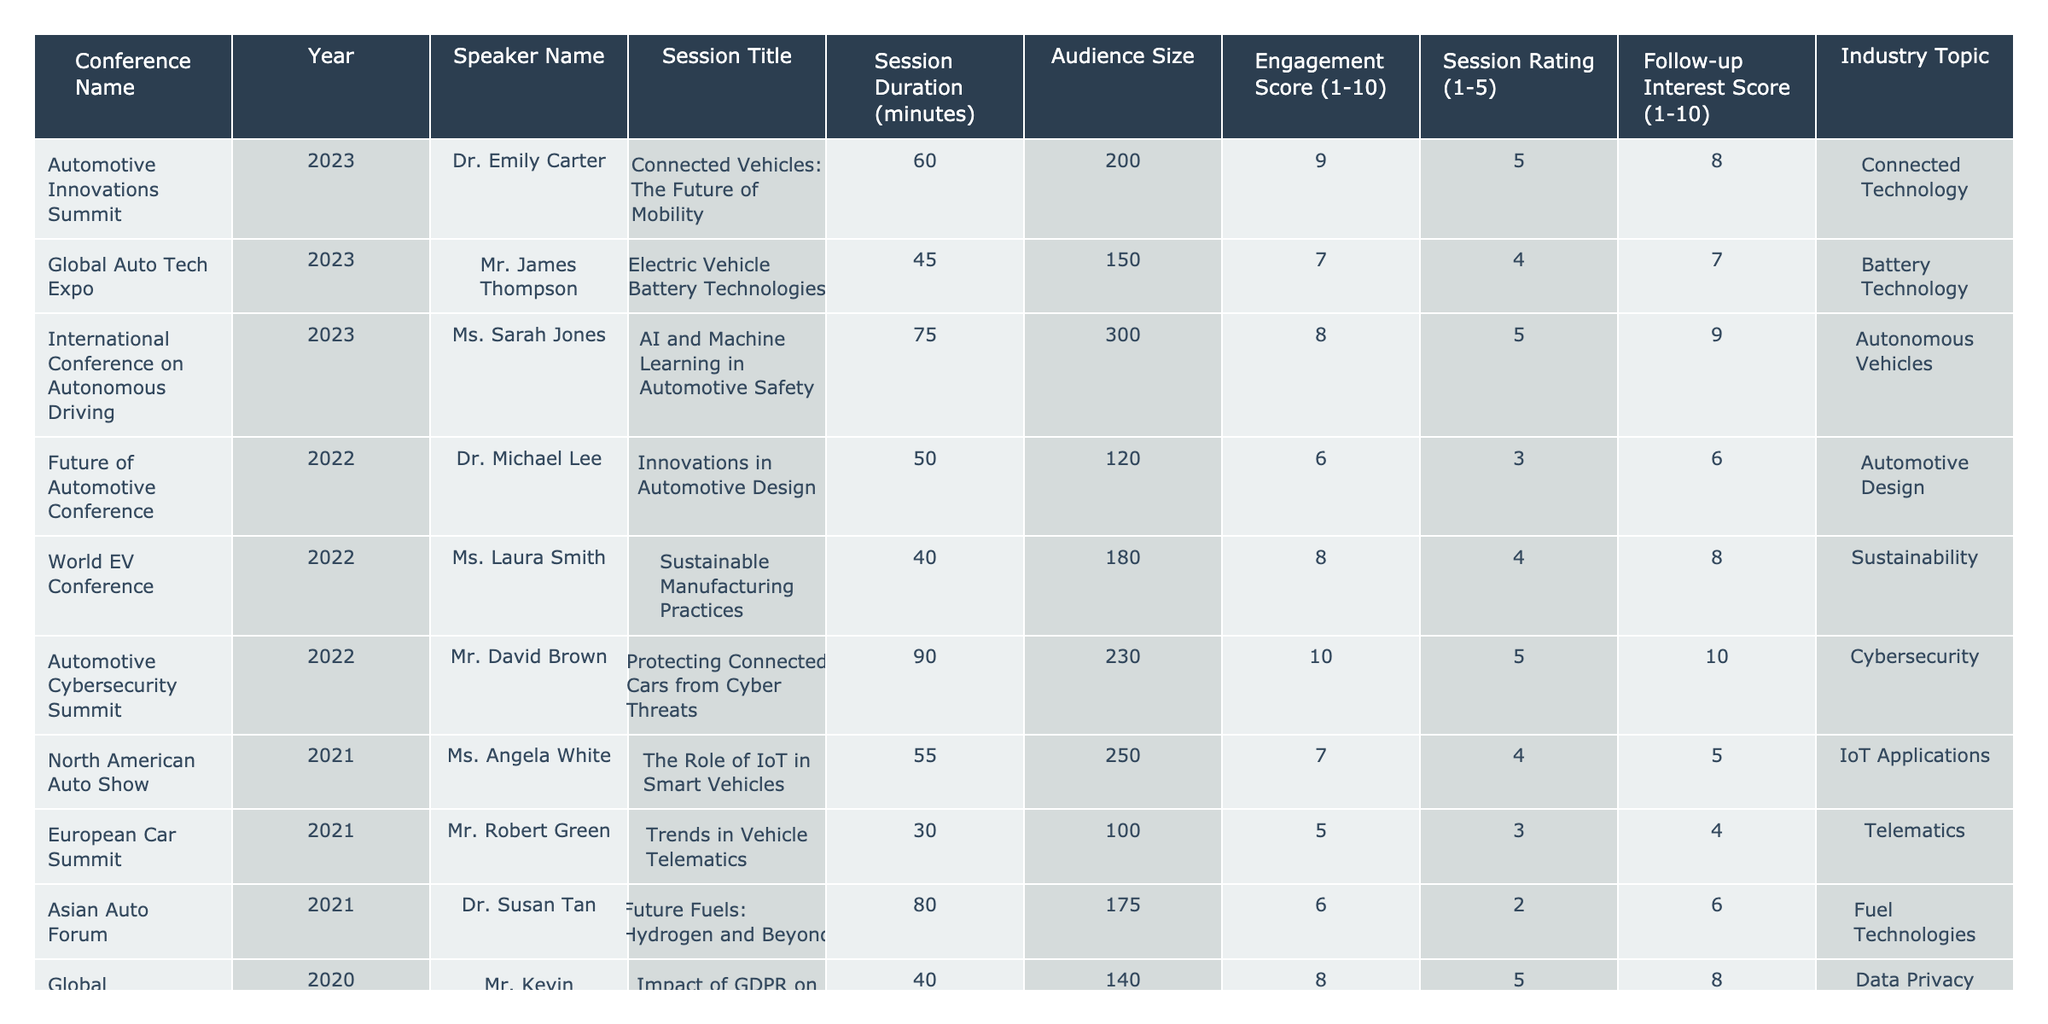What is the engagement score of Dr. Emily Carter's session? The table lists Dr. Emily Carter's session with an engagement score of 9 out of 10.
Answer: 9 Which session had the highest session rating? The session titled "Protecting Connected Cars from Cyber Threats" by Mr. David Brown has the highest session rating of 5.
Answer: 5 What is the average audience size for all sessions in 2022? The audience sizes for 2022 are 120, 180, and 230. The average is calculated as (120 + 180 + 230) / 3 = 510 / 3 = 170.
Answer: 170 Did any sessions in 2023 have a follow-up interest score of 10? Looking at the table, the session "Protecting Connected Cars from Cyber Threats" in 2022 had a follow-up interest score of 10, but no sessions in 2023 had a follow-up interest score of 10.
Answer: No What is the difference between the highest and lowest session ratings in 2023? In 2023, the highest session rating is 5 (Dr. Emily Carter and Ms. Sarah Jones), and the lowest is 4 (Mr. James Thompson). The difference is 5 - 4 = 1.
Answer: 1 Which speaker presented on the topic of "Battery Technology"? The speaker for the "Battery Technology" topic is Mr. James Thompson at the "Global Auto Tech Expo" in 2023.
Answer: Mr. James Thompson What was the session duration for the session with the lowest engagement score? The session "Future Fuels: Hydrogen and Beyond" by Dr. Susan Tan had the lowest engagement score of 6 and its duration was 80 minutes.
Answer: 80 minutes How many sessions had an audience size greater than 200? There are three sessions with an audience size greater than 200. They are "Connected Vehicles: The Future of Mobility", "Protecting Connected Cars from Cyber Threats", and "The Role of IoT in Smart Vehicles".
Answer: 3 Which session and speaker had the second-highest engagement score? The session "AI and Machine Learning in Automotive Safety" by Ms. Sarah Jones had the second-highest engagement score of 8 out of 10.
Answer: Ms. Sarah Jones What is the median session duration across all sessions? The session durations are 60, 45, 75, 50, 40, 90, 55, 30, 80, and 40 minutes. When sorted, the values are 30, 40, 40, 45, 50, 55, 60, 75, 80, and 90. The median is the average of the 5th and 6th values: (50 + 55) / 2 = 52.5.
Answer: 52.5 How many speakers presented sessions on "Sustainability"? Only one speaker, Ms. Laura Smith, presented on the topic of "Sustainability" in the session titled "Sustainable Manufacturing Practices".
Answer: 1 